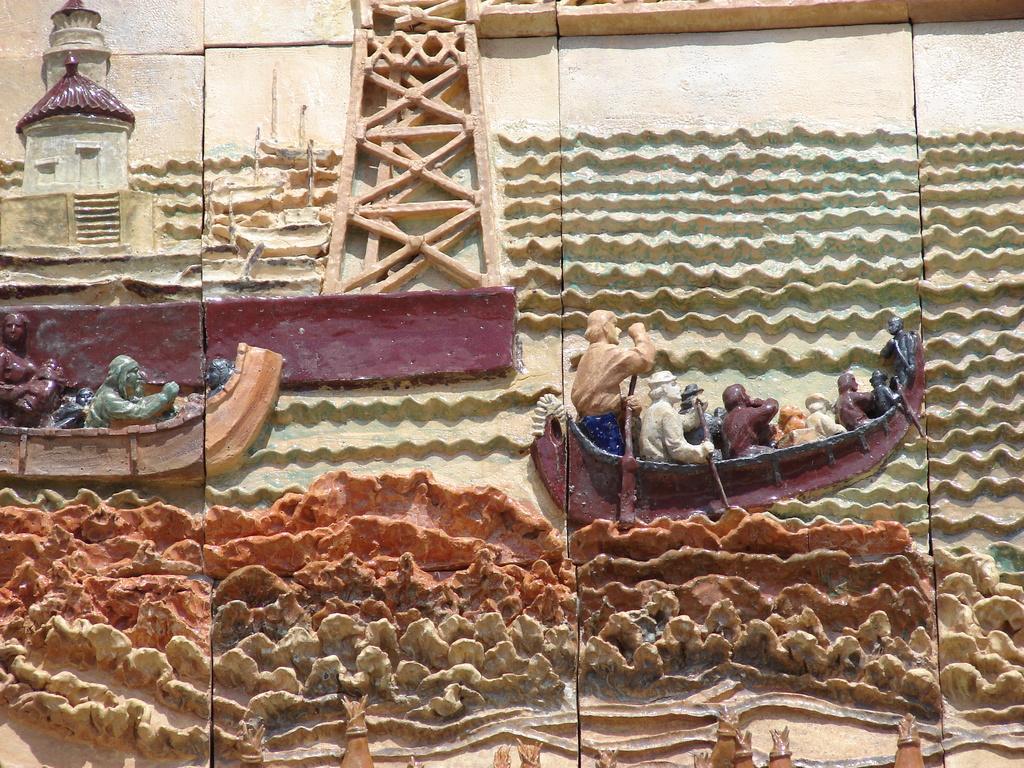How would you summarize this image in a sentence or two? This image is taken outdoors. In this image there is a wall with carvings on it. There are two boats, a tower and a few people on it. 